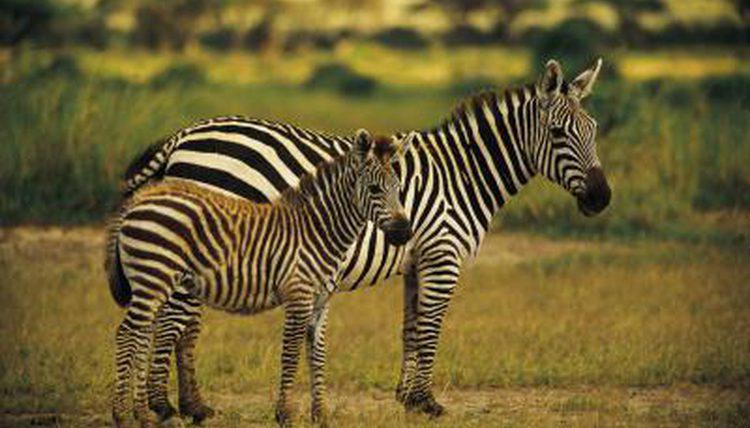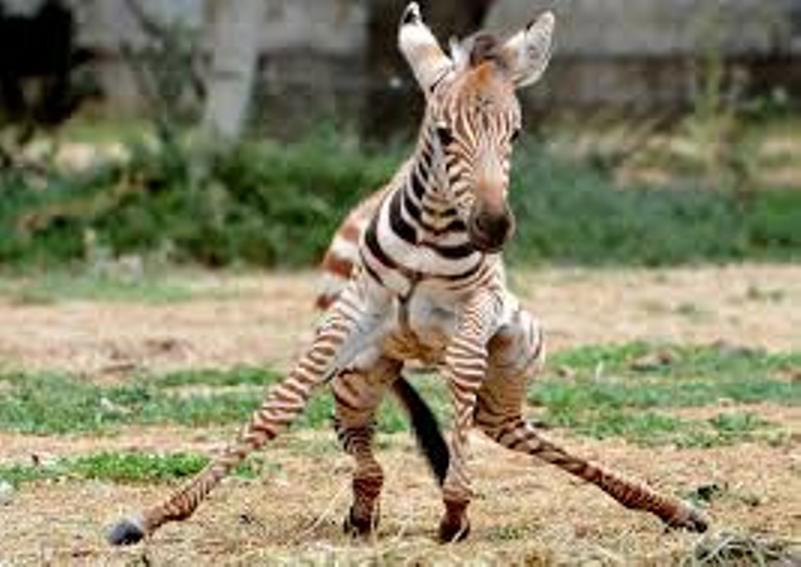The first image is the image on the left, the second image is the image on the right. For the images displayed, is the sentence "One image has a zebra laying on the ground." factually correct? Answer yes or no. No. The first image is the image on the left, the second image is the image on the right. Evaluate the accuracy of this statement regarding the images: "The left image shows a zebra colt standing alongside and in front of an adult zebra that faces the same direction, and the right image contains only a zebra colt, which faces forward and is not standing upright.". Is it true? Answer yes or no. Yes. 